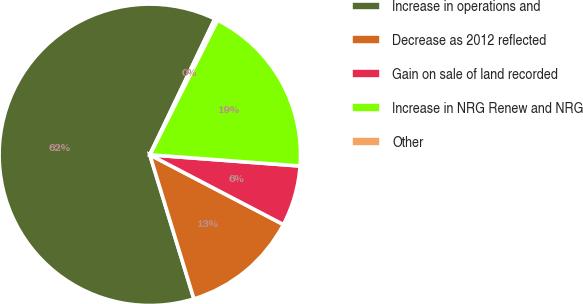Convert chart to OTSL. <chart><loc_0><loc_0><loc_500><loc_500><pie_chart><fcel>Increase in operations and<fcel>Decrease as 2012 reflected<fcel>Gain on sale of land recorded<fcel>Increase in NRG Renew and NRG<fcel>Other<nl><fcel>61.82%<fcel>12.62%<fcel>6.47%<fcel>18.77%<fcel>0.32%<nl></chart> 